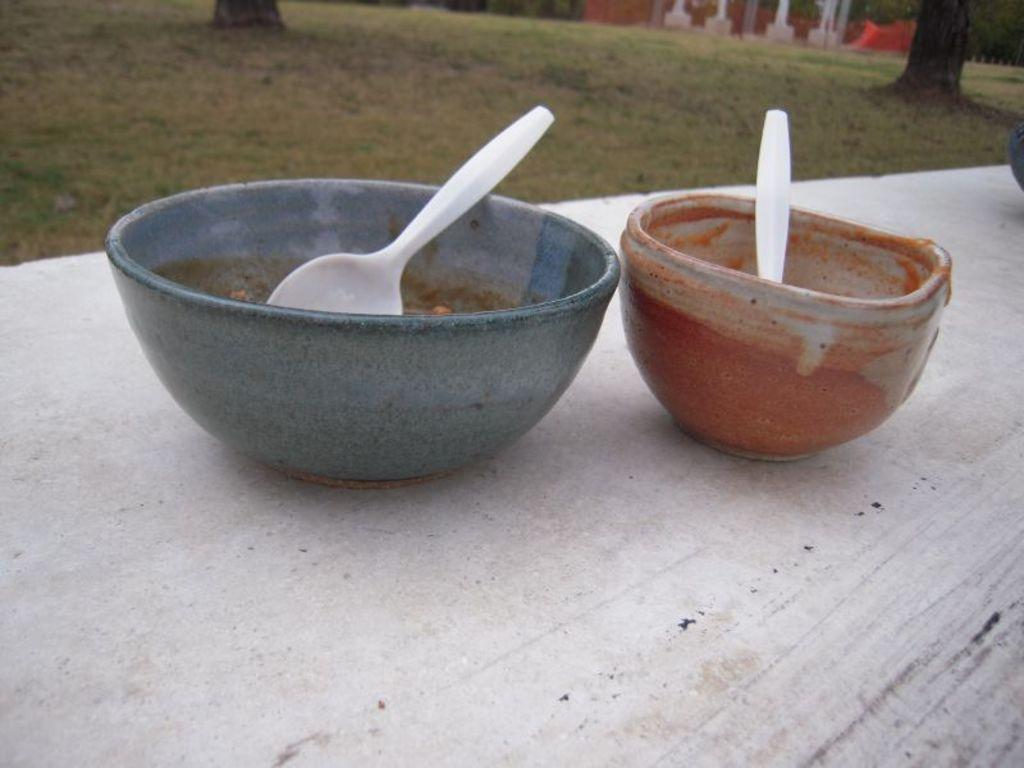How many bowls are present in the image? There are two bowls in the image. What is inside the bowls? There are spoons in the bowls. What type of vegetation can be seen in the image? Trees are visible in the image. What is the ground surface like in the image? There is grassland in the image. What structure can be seen in the background of the image? There appears to be a house in the background of the image. What type of band is playing in the room in the image? There is no band or room present in the image; it features two bowls with spoons, trees, grassland, and a house in the background. How many cherries are on the grass in the image? There are no cherries visible in the image. 